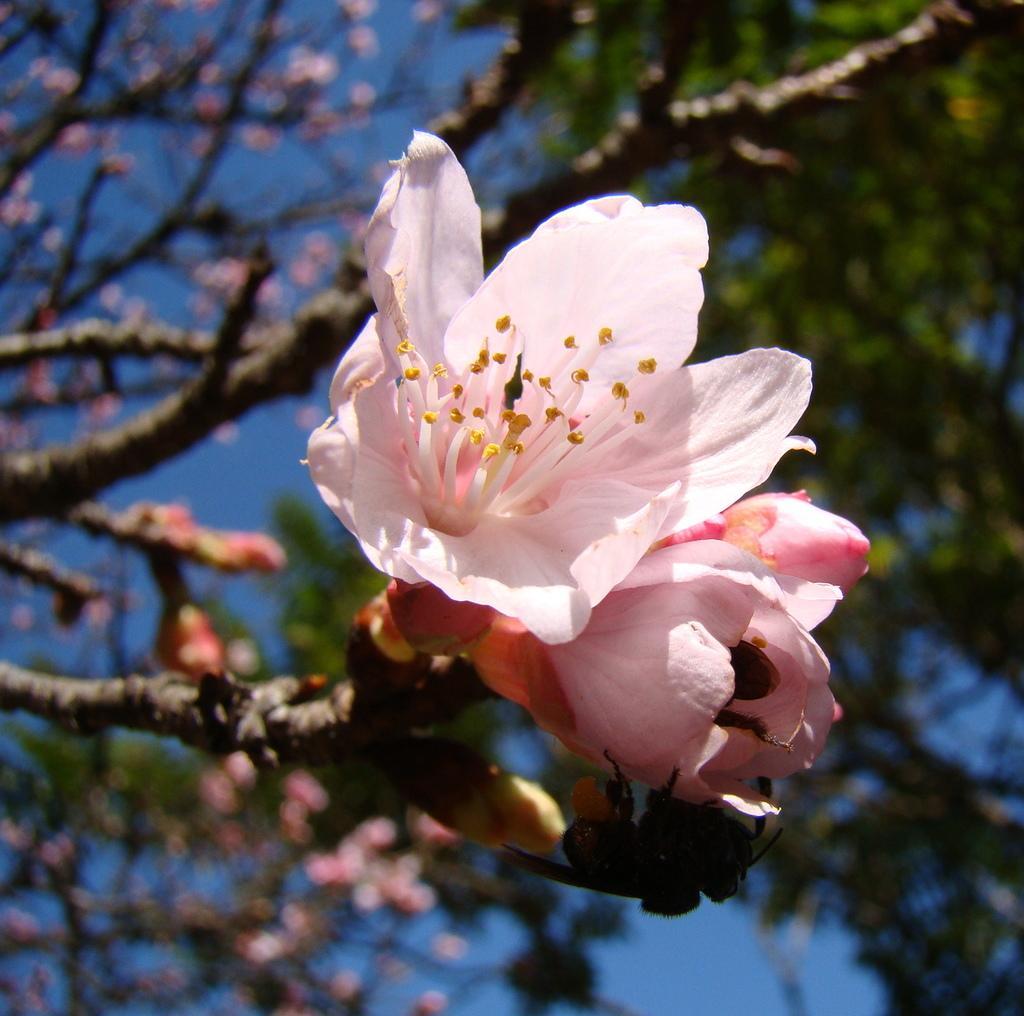Could you give a brief overview of what you see in this image? There are flowers to a tree in the foreground area of the image, there are trees and the sky in the background. 